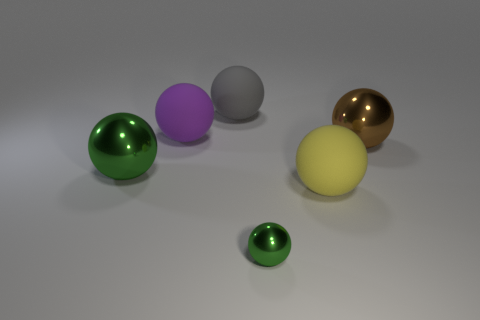Are there any other small objects of the same color as the small object?
Keep it short and to the point. No. What number of things are metallic things behind the yellow sphere or big matte things?
Provide a succinct answer. 5. Are the tiny ball and the big green sphere that is on the left side of the big yellow matte object made of the same material?
Give a very brief answer. Yes. There is another metallic ball that is the same color as the tiny sphere; what size is it?
Make the answer very short. Large. Is there a purple object made of the same material as the purple sphere?
Keep it short and to the point. No. How many objects are matte balls in front of the large green metallic object or large spheres that are to the right of the purple matte object?
Your response must be concise. 3. There is a large yellow thing; is it the same shape as the gray thing that is to the left of the small green thing?
Give a very brief answer. Yes. What number of other objects are the same shape as the gray object?
Your answer should be compact. 5. How many objects are either large red cubes or large gray balls?
Your answer should be very brief. 1. Is there any other thing that is the same size as the brown sphere?
Make the answer very short. Yes. 